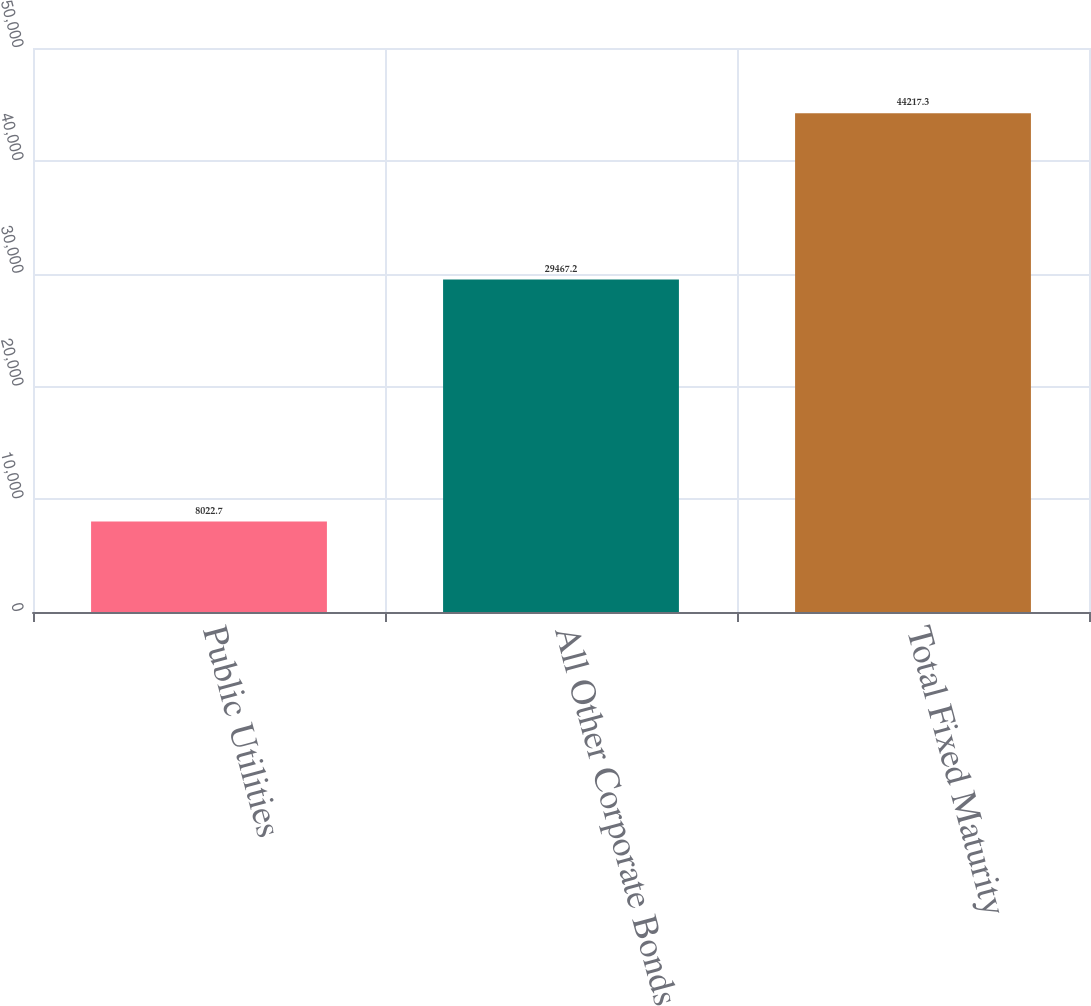Convert chart to OTSL. <chart><loc_0><loc_0><loc_500><loc_500><bar_chart><fcel>Public Utilities<fcel>All Other Corporate Bonds<fcel>Total Fixed Maturity<nl><fcel>8022.7<fcel>29467.2<fcel>44217.3<nl></chart> 